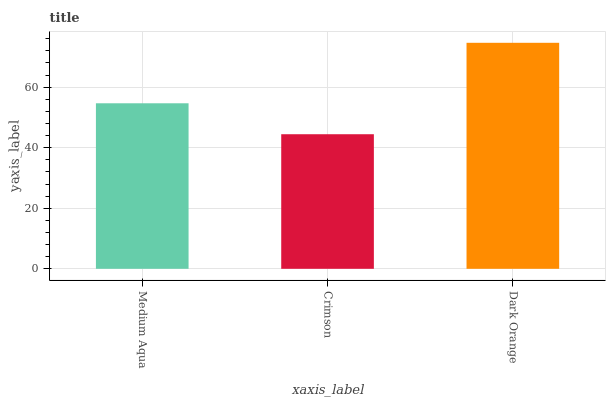Is Crimson the minimum?
Answer yes or no. Yes. Is Dark Orange the maximum?
Answer yes or no. Yes. Is Dark Orange the minimum?
Answer yes or no. No. Is Crimson the maximum?
Answer yes or no. No. Is Dark Orange greater than Crimson?
Answer yes or no. Yes. Is Crimson less than Dark Orange?
Answer yes or no. Yes. Is Crimson greater than Dark Orange?
Answer yes or no. No. Is Dark Orange less than Crimson?
Answer yes or no. No. Is Medium Aqua the high median?
Answer yes or no. Yes. Is Medium Aqua the low median?
Answer yes or no. Yes. Is Crimson the high median?
Answer yes or no. No. Is Dark Orange the low median?
Answer yes or no. No. 